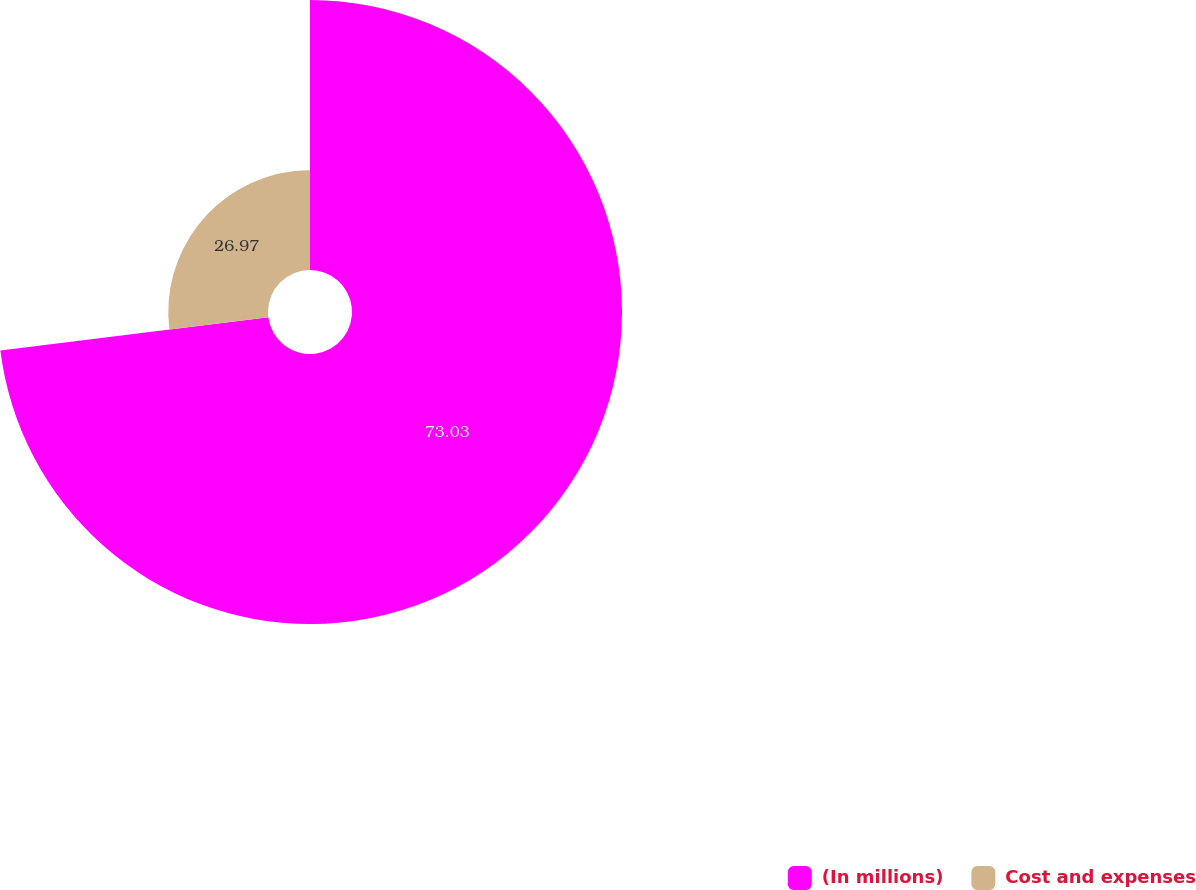Convert chart. <chart><loc_0><loc_0><loc_500><loc_500><pie_chart><fcel>(In millions)<fcel>Cost and expenses<nl><fcel>73.03%<fcel>26.97%<nl></chart> 